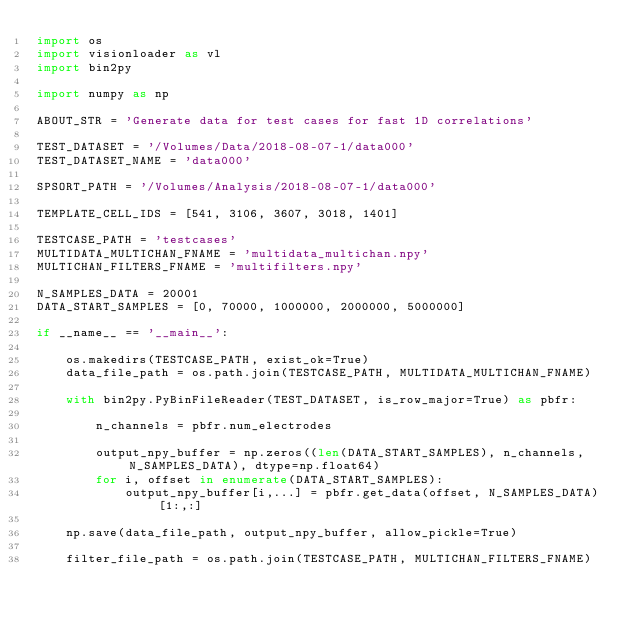Convert code to text. <code><loc_0><loc_0><loc_500><loc_500><_Python_>import os
import visionloader as vl
import bin2py

import numpy as np

ABOUT_STR = 'Generate data for test cases for fast 1D correlations'

TEST_DATASET = '/Volumes/Data/2018-08-07-1/data000'
TEST_DATASET_NAME = 'data000'

SPSORT_PATH = '/Volumes/Analysis/2018-08-07-1/data000'

TEMPLATE_CELL_IDS = [541, 3106, 3607, 3018, 1401]

TESTCASE_PATH = 'testcases'
MULTIDATA_MULTICHAN_FNAME = 'multidata_multichan.npy'
MULTICHAN_FILTERS_FNAME = 'multifilters.npy'

N_SAMPLES_DATA = 20001
DATA_START_SAMPLES = [0, 70000, 1000000, 2000000, 5000000]

if __name__ == '__main__':

    os.makedirs(TESTCASE_PATH, exist_ok=True)
    data_file_path = os.path.join(TESTCASE_PATH, MULTIDATA_MULTICHAN_FNAME)

    with bin2py.PyBinFileReader(TEST_DATASET, is_row_major=True) as pbfr:

        n_channels = pbfr.num_electrodes

        output_npy_buffer = np.zeros((len(DATA_START_SAMPLES), n_channels, N_SAMPLES_DATA), dtype=np.float64)
        for i, offset in enumerate(DATA_START_SAMPLES):
            output_npy_buffer[i,...] = pbfr.get_data(offset, N_SAMPLES_DATA)[1:,:]

    np.save(data_file_path, output_npy_buffer, allow_pickle=True)

    filter_file_path = os.path.join(TESTCASE_PATH, MULTICHAN_FILTERS_FNAME)</code> 